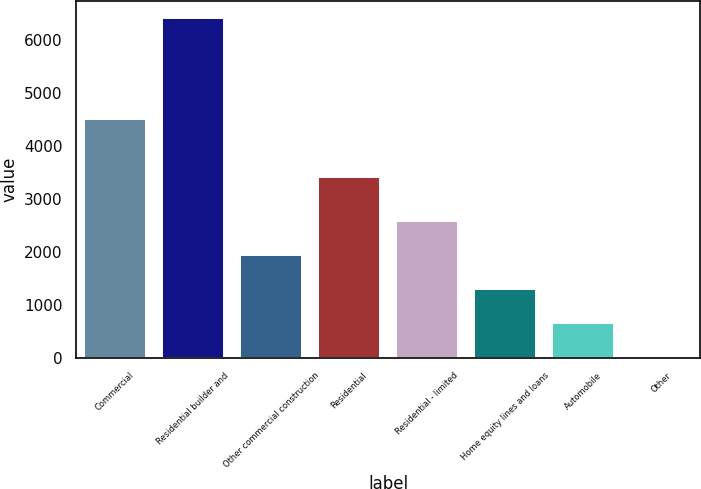Convert chart. <chart><loc_0><loc_0><loc_500><loc_500><bar_chart><fcel>Commercial<fcel>Residential builder and<fcel>Other commercial construction<fcel>Residential<fcel>Residential - limited<fcel>Home equity lines and loans<fcel>Automobile<fcel>Other<nl><fcel>4497<fcel>6419<fcel>1933.4<fcel>3406<fcel>2574.2<fcel>1292.6<fcel>651.8<fcel>11<nl></chart> 